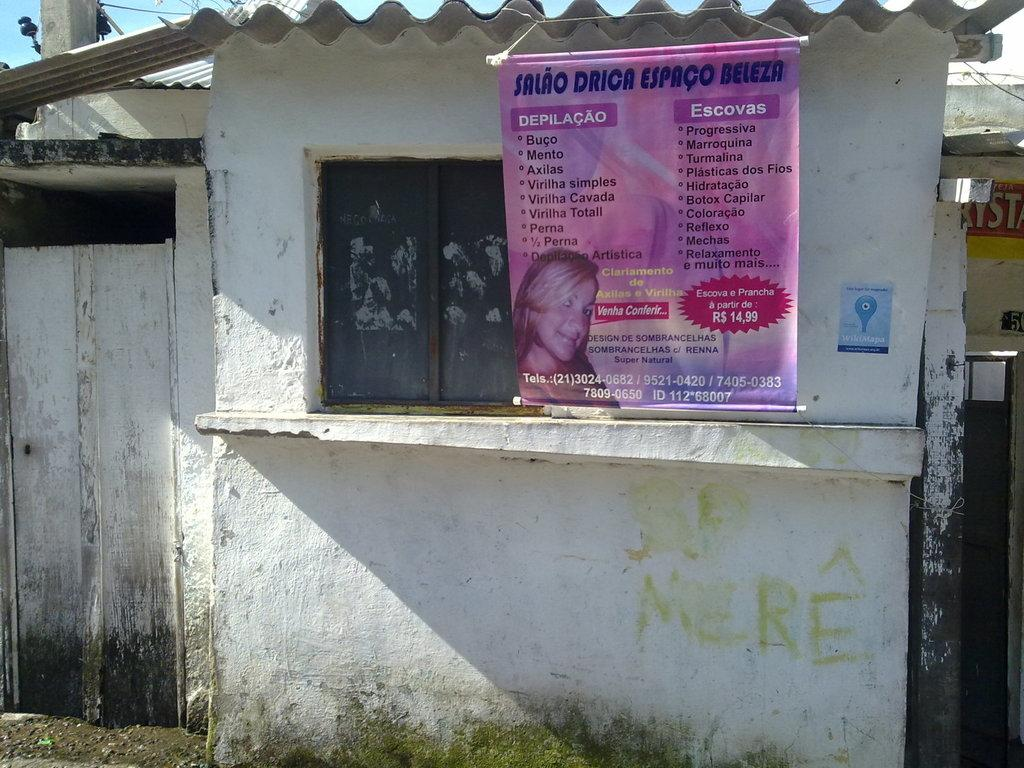What type of structure is in the image? There is a house in the image. What features can be seen on the house? The house has a roof, windows, and a door. What is written or displayed on the wall? There is a banner with text on a wall. What else is visible in the image? There is a pole visible in the image, and the sky is visible as well. Can you tell me how many sisters are playing with the train in the image? There is no train or sisters present in the image; it features a house with a roof, windows, and a door, along with a banner, pole, and visible sky. 